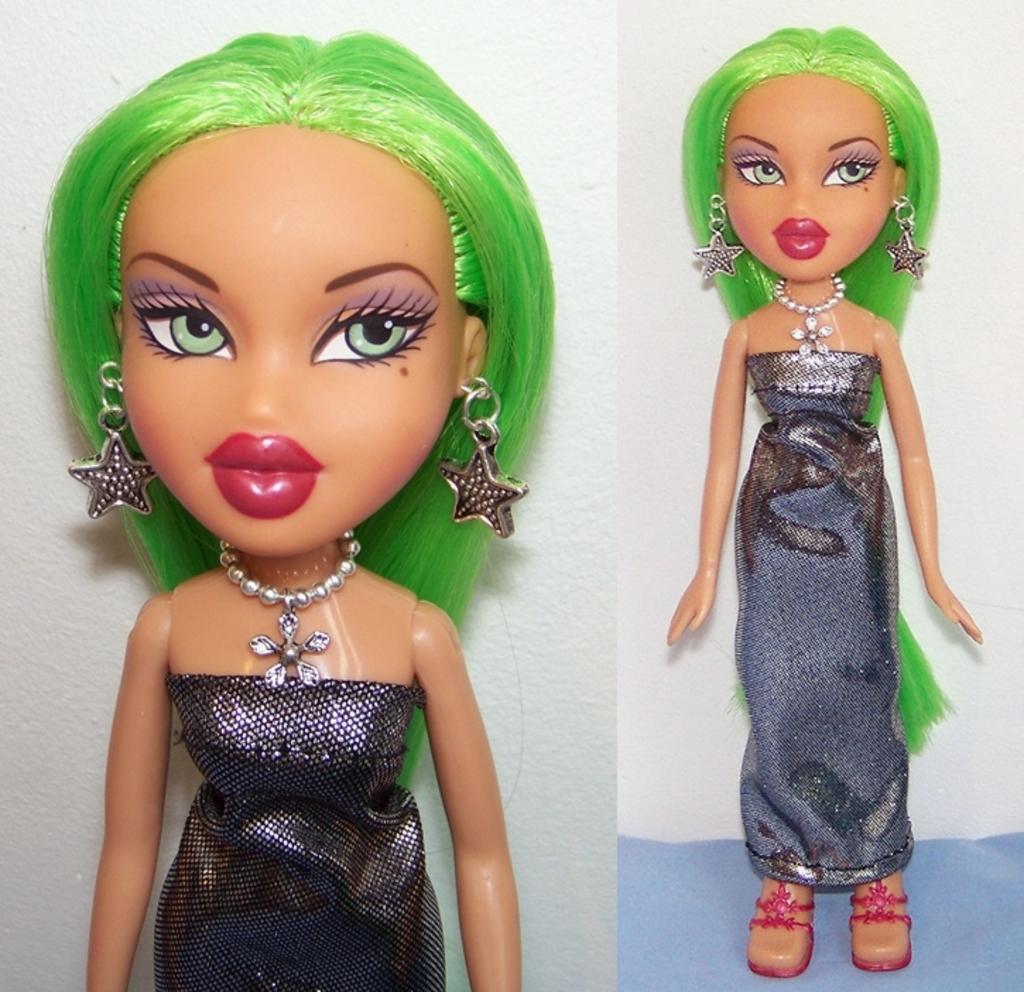Please provide a concise description of this image. This is a collage picture and in this picture we can see a doll and in the background we can see the wall. 